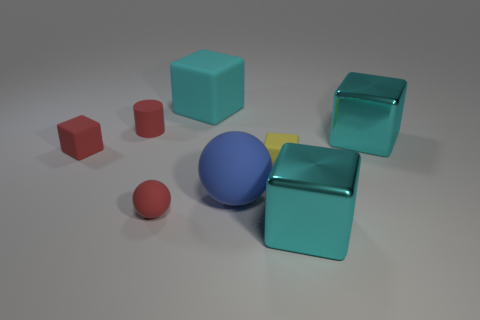Subtract all brown cylinders. How many cyan blocks are left? 3 Subtract all tiny yellow matte cubes. How many cubes are left? 4 Subtract 1 blocks. How many blocks are left? 4 Subtract all red cubes. How many cubes are left? 4 Subtract all blue cylinders. Subtract all cyan cubes. How many cylinders are left? 1 Add 2 large cyan matte cubes. How many objects exist? 10 Subtract all balls. How many objects are left? 6 Subtract all large gray shiny cylinders. Subtract all tiny rubber objects. How many objects are left? 4 Add 2 tiny red matte objects. How many tiny red matte objects are left? 5 Add 6 tiny matte objects. How many tiny matte objects exist? 10 